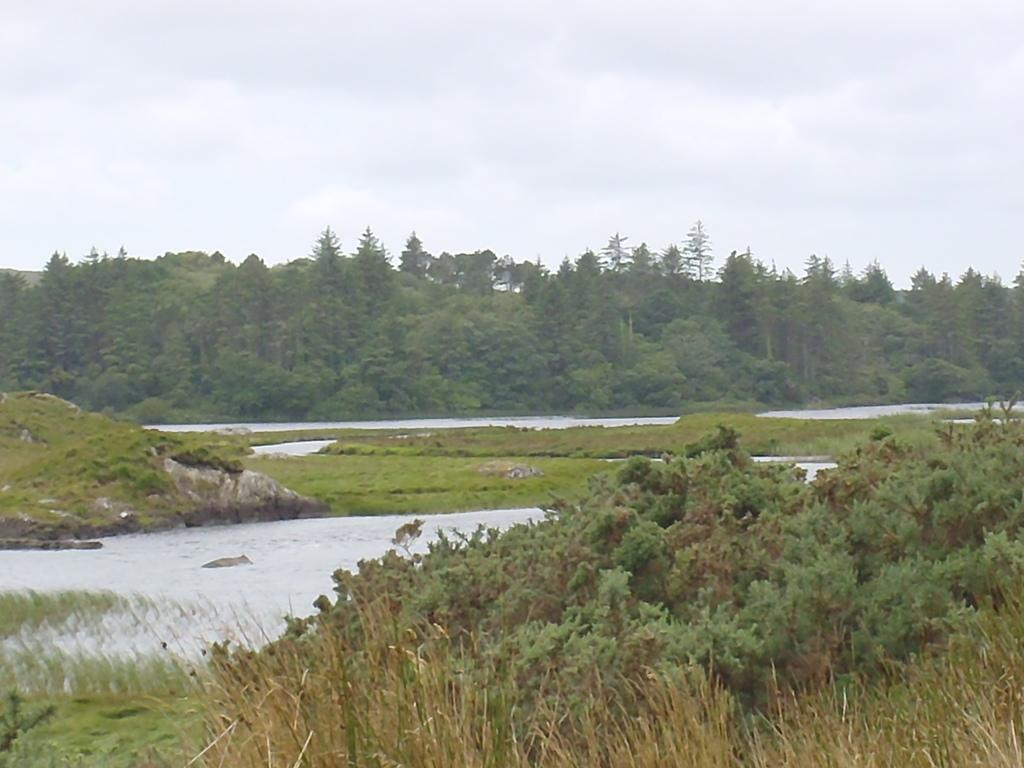What type of plants can be seen in the image? There are grass plants in the image. What else is visible besides the grass plants? There is water visible in the image. What can be seen in the background of the image? There are trees and the sky visible in the background of the image. What is the condition of the sky in the image? Clouds are present in the sky. What type of badge is the secretary wearing in the image? There is no secretary or badge present in the image. How much dirt is visible on the grass plants in the image? There is no dirt visible on the grass plants in the image; they appear to be clean. 